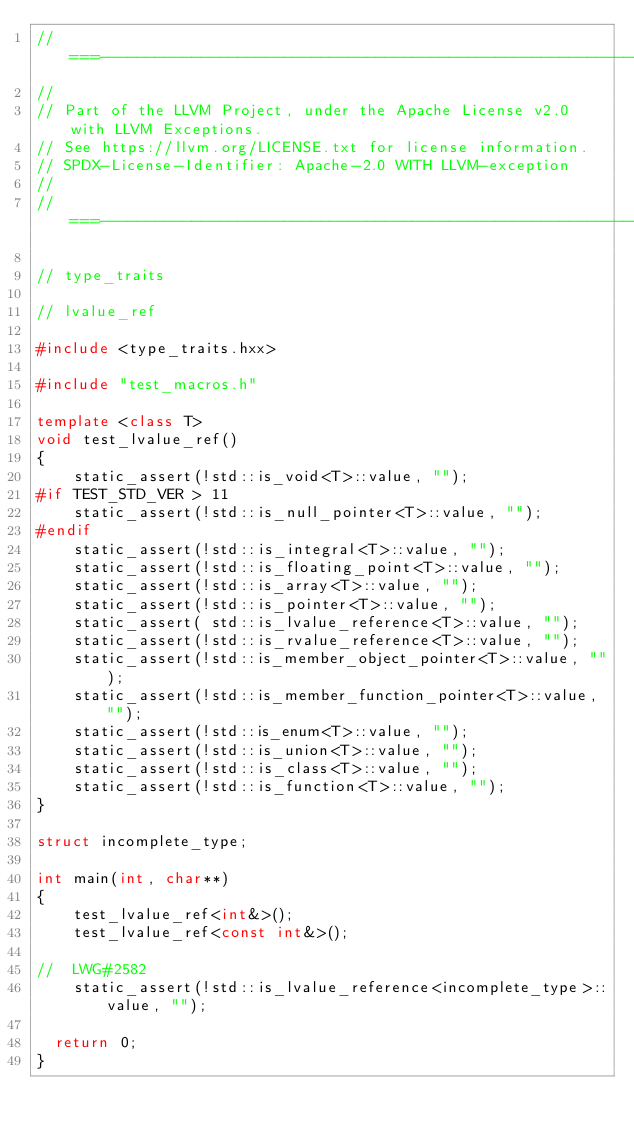<code> <loc_0><loc_0><loc_500><loc_500><_C++_>//===----------------------------------------------------------------------===//
//
// Part of the LLVM Project, under the Apache License v2.0 with LLVM Exceptions.
// See https://llvm.org/LICENSE.txt for license information.
// SPDX-License-Identifier: Apache-2.0 WITH LLVM-exception
//
//===----------------------------------------------------------------------===//

// type_traits

// lvalue_ref

#include <type_traits.hxx>

#include "test_macros.h"

template <class T>
void test_lvalue_ref()
{
    static_assert(!std::is_void<T>::value, "");
#if TEST_STD_VER > 11
    static_assert(!std::is_null_pointer<T>::value, "");
#endif
    static_assert(!std::is_integral<T>::value, "");
    static_assert(!std::is_floating_point<T>::value, "");
    static_assert(!std::is_array<T>::value, "");
    static_assert(!std::is_pointer<T>::value, "");
    static_assert( std::is_lvalue_reference<T>::value, "");
    static_assert(!std::is_rvalue_reference<T>::value, "");
    static_assert(!std::is_member_object_pointer<T>::value, "");
    static_assert(!std::is_member_function_pointer<T>::value, "");
    static_assert(!std::is_enum<T>::value, "");
    static_assert(!std::is_union<T>::value, "");
    static_assert(!std::is_class<T>::value, "");
    static_assert(!std::is_function<T>::value, "");
}

struct incomplete_type;

int main(int, char**)
{
    test_lvalue_ref<int&>();
    test_lvalue_ref<const int&>();

//  LWG#2582
    static_assert(!std::is_lvalue_reference<incomplete_type>::value, "");

  return 0;
}
</code> 